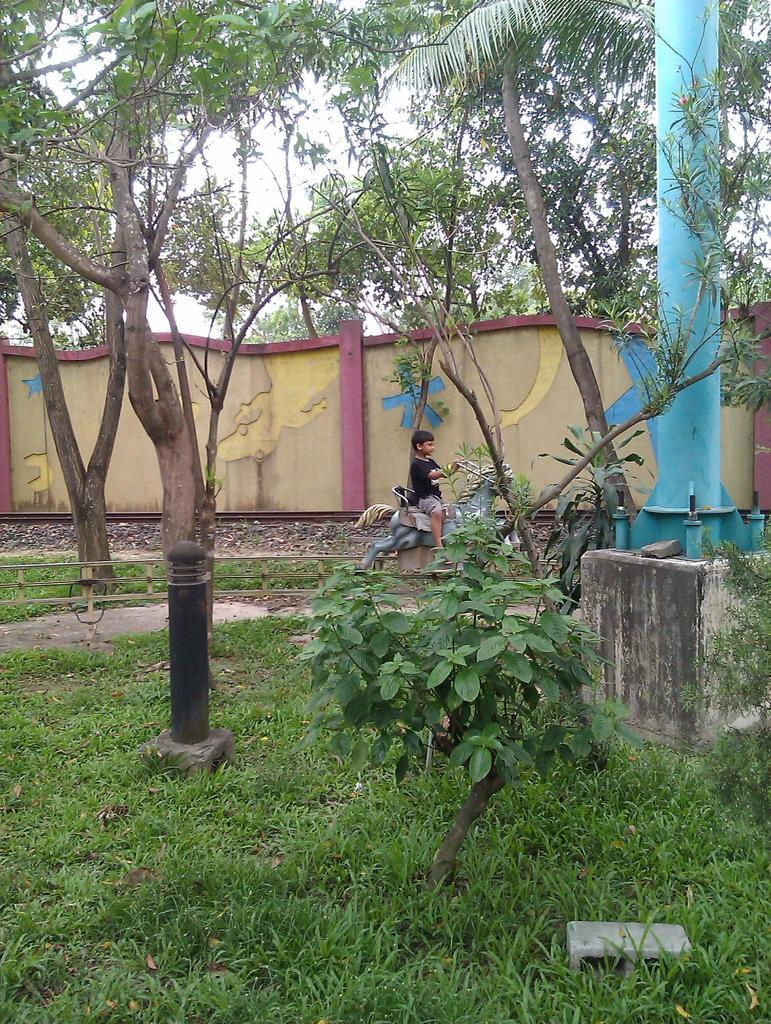What type of vegetation is present in the image? There is grass in the image. What structures can be seen in the image? There are poles and a wall in the image. What else is present in the image besides the grass and structures? There are trees in the image. What is the boy in the image doing? The boy is sitting on a toy horse in the image. What can be seen in the background of the image? The sky is visible in the background of the image. How does the boy pull the sponge in the image? There is no sponge present in the image, and the boy is sitting on a toy horse, not pulling anything. 